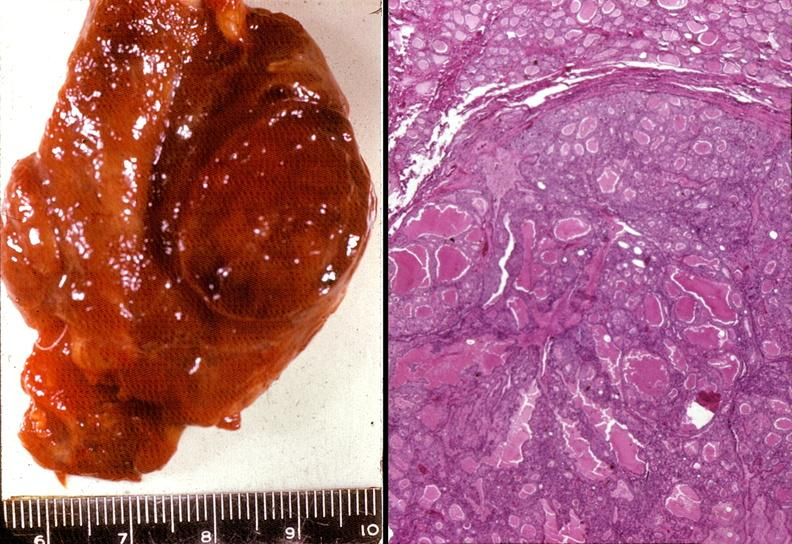does this image shows of smooth muscle cell with lipid in sarcoplasm and lipid show thyroid, follicular adenoma?
Answer the question using a single word or phrase. No 